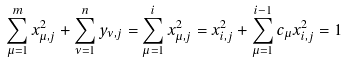Convert formula to latex. <formula><loc_0><loc_0><loc_500><loc_500>\sum _ { \mu = 1 } ^ { m } x ^ { 2 } _ { \mu , j } + \sum _ { \nu = 1 } ^ { n } y _ { \nu , j } = \sum _ { \mu = 1 } ^ { i } x ^ { 2 } _ { \mu , j } = x ^ { 2 } _ { i , j } + \sum _ { \mu = 1 } ^ { i - 1 } c _ { \mu } x ^ { 2 } _ { i , j } = 1</formula> 